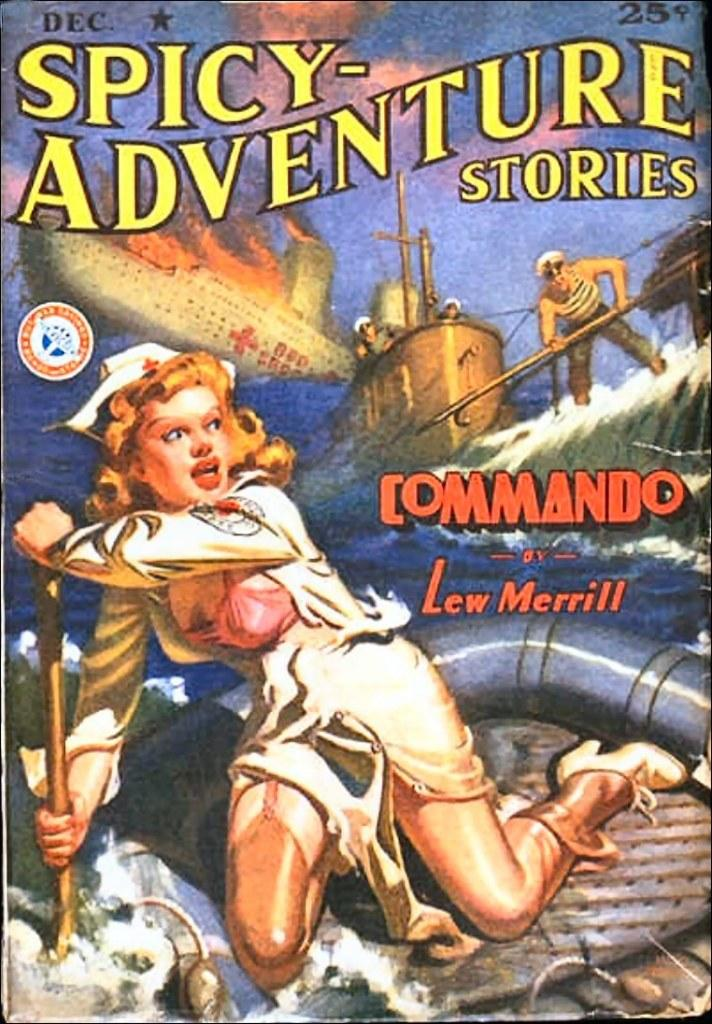<image>
Summarize the visual content of the image. A woman is fleeing in a raft from a submarine on the cover of a novel called Spicy-Adventure Stories. 